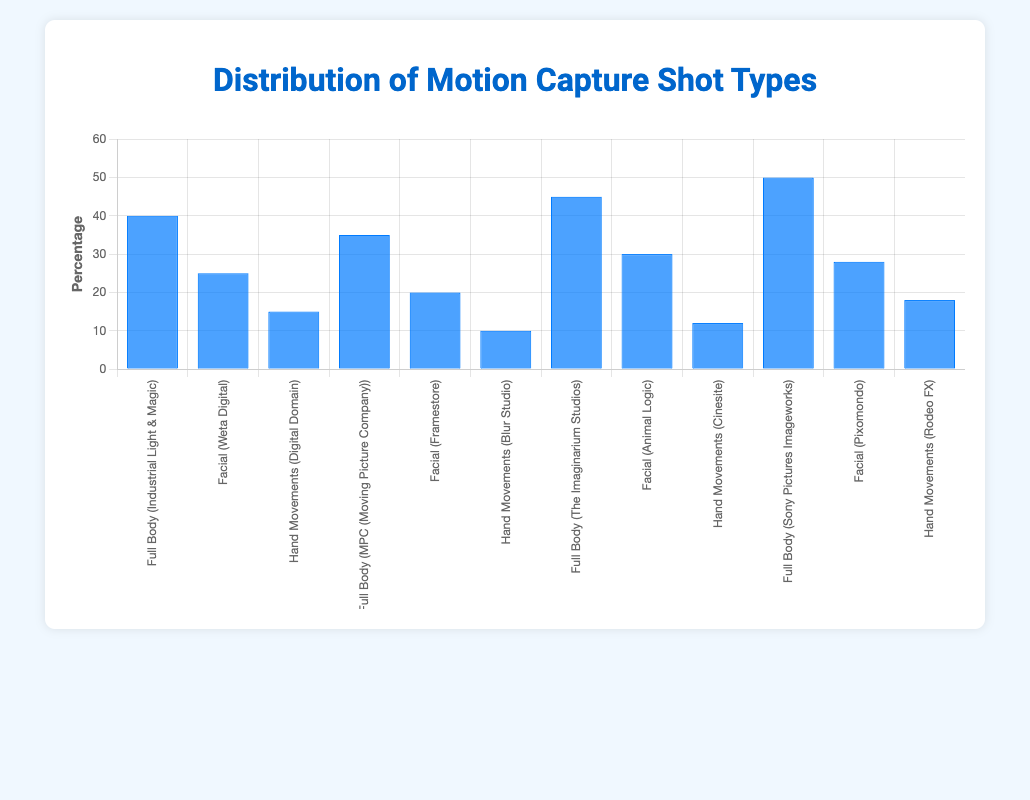What is the percentage of Facial motion capture shots done by Weta Digital? Refer to the specific bar's percentage for Facial motion capture shots listed under Weta Digital.
Answer: 25 Which studio has the highest percentage of Full Body motion capture shots? Compare the Full Body motion capture shots across all studios to identify the highest percentage, which is from Sony Pictures Imageworks.
Answer: Sony Pictures Imageworks What is the combined percentage of Hand Movements motion capture shots from Digital Domain and Rodeo FX? Add the percentages for Hand Movements from Digital Domain (15%) and Rodeo FX (18%).
Answer: 33 Which type of motion capture shot has the lowest percentage, and which studio performs it? Observe the bars representing the different types of motion capture shots to find the lowest percentage, which is Hand Movements by Blur Studio.
Answer: Hand Movements by Blur Studio What is the difference in percentage between Full Body motion capture shots performed by MPC and The Imaginarium Studios? Subtract the percentage of Full Body shots by MPC (35%) from The Imaginarium Studios (45%).
Answer: 10 Which studios perform Facial motion capture shots at a percentage greater than 25%? Identify the bars indicating Facial motion capture shots with percentages greater than 25: Animal Logic (30%) and Pixomondo (28%).
Answer: Animal Logic, Pixomondo What is the average percentage of Hand Movements motion capture shots across all studios? Sum the percentages of Hand Movements shots from all studios and divide by the number of data points (6). (15 + 10 + 12 + 18) / 4
Answer: 13.75 How does the average percentage of Facial motion capture shots compare to the average percentage of Hand Movements motion capture shots? Calculate the average percentage for both Facial and Hand Movements shots and compare. Average for Facial: (25 + 20 + 30 + 28) / 4 = 25.75. Average for Hand Movements: (15 + 10 + 12 + 18) / 4 = 13.75. Facial shots average is higher.
Answer: Facial shots average is higher Which type of motion capture shot is most frequently performed at a percentage of 40% or higher? Identify bars with percentages of 40% or higher and categorize by type: Full Body.
Answer: Full Body 